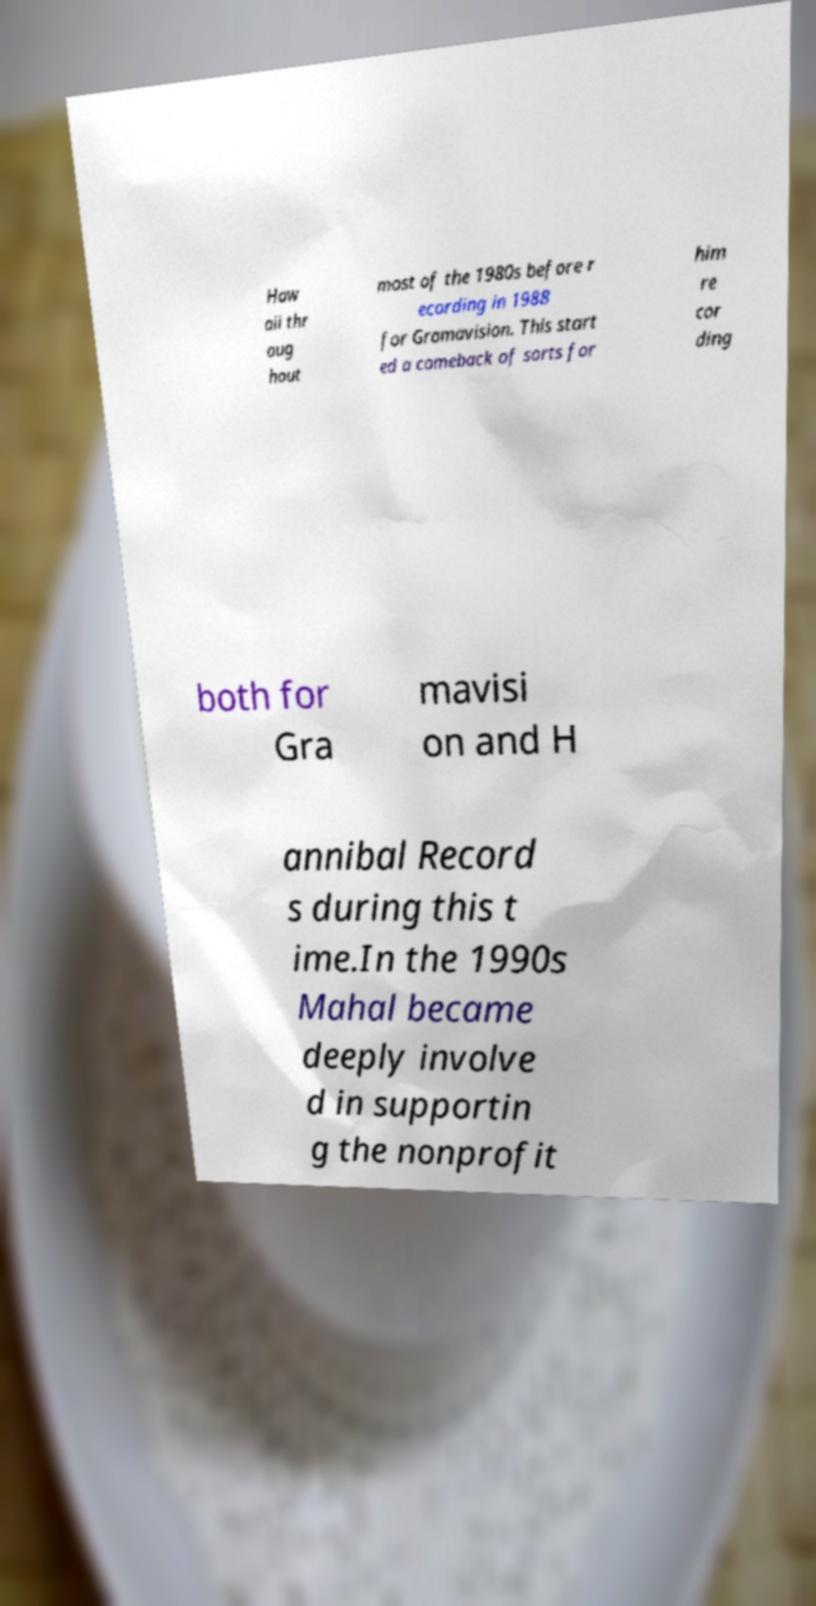Can you accurately transcribe the text from the provided image for me? Haw aii thr oug hout most of the 1980s before r ecording in 1988 for Gramavision. This start ed a comeback of sorts for him re cor ding both for Gra mavisi on and H annibal Record s during this t ime.In the 1990s Mahal became deeply involve d in supportin g the nonprofit 